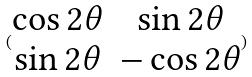<formula> <loc_0><loc_0><loc_500><loc_500>( \begin{matrix} \cos 2 \theta & \sin 2 \theta \\ \sin 2 \theta & - \cos 2 \theta \end{matrix} )</formula> 